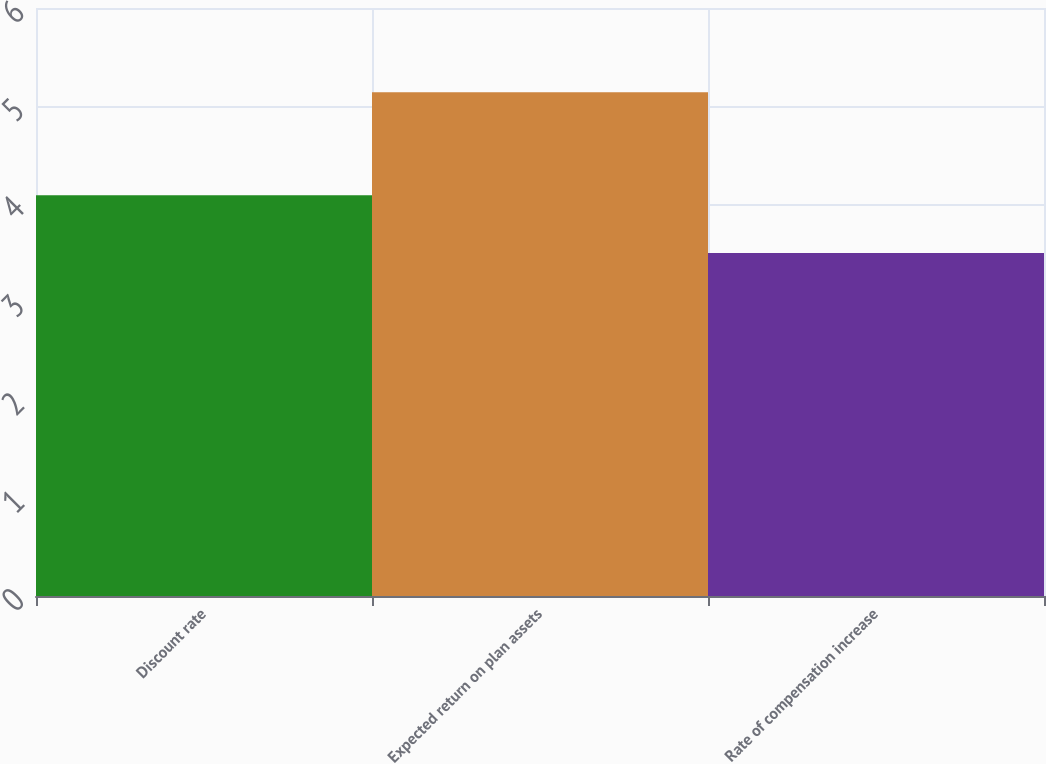Convert chart to OTSL. <chart><loc_0><loc_0><loc_500><loc_500><bar_chart><fcel>Discount rate<fcel>Expected return on plan assets<fcel>Rate of compensation increase<nl><fcel>4.09<fcel>5.14<fcel>3.5<nl></chart> 